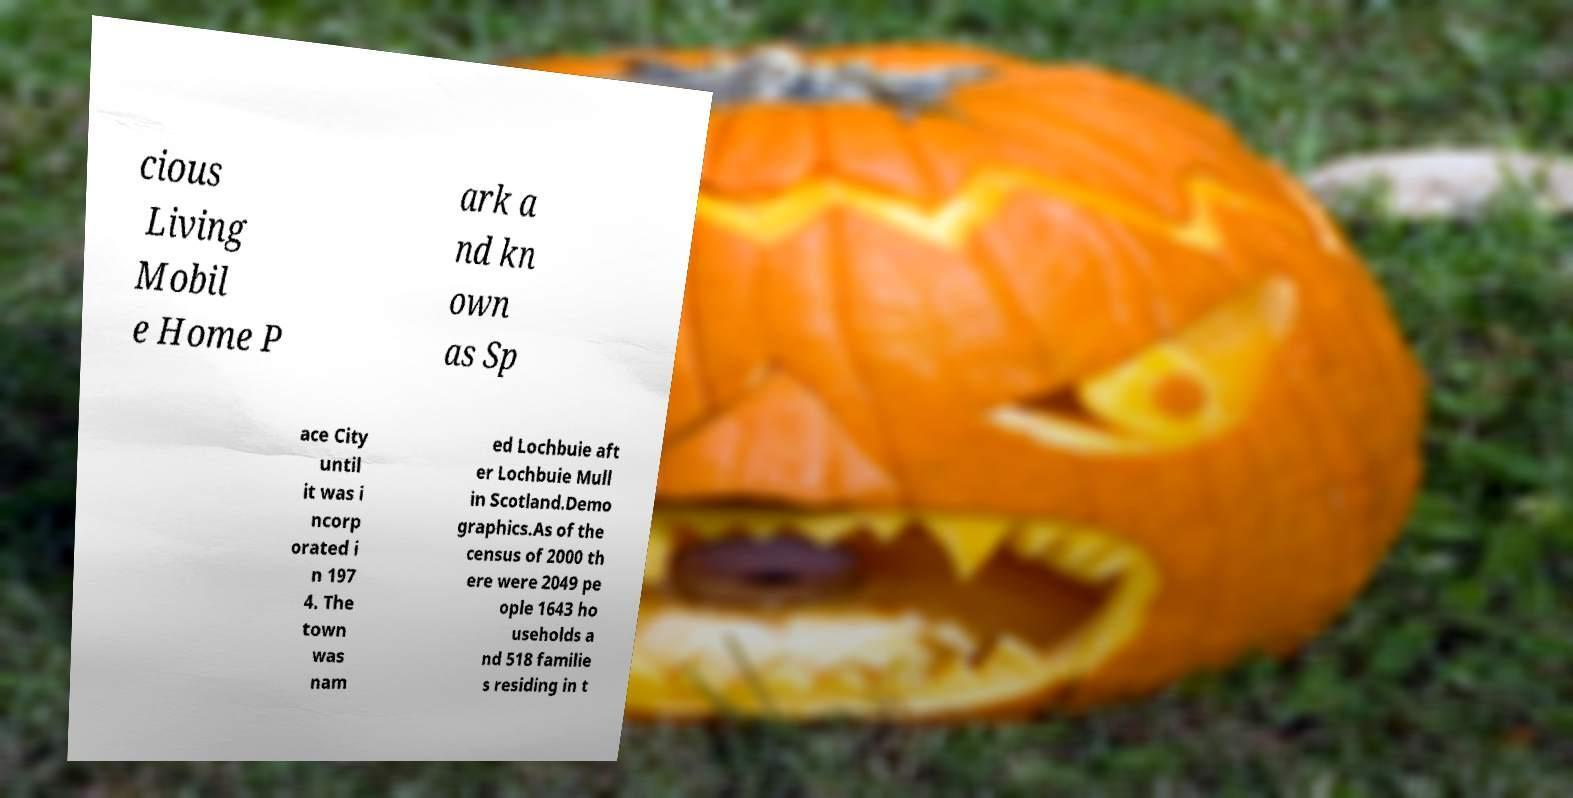Can you read and provide the text displayed in the image?This photo seems to have some interesting text. Can you extract and type it out for me? cious Living Mobil e Home P ark a nd kn own as Sp ace City until it was i ncorp orated i n 197 4. The town was nam ed Lochbuie aft er Lochbuie Mull in Scotland.Demo graphics.As of the census of 2000 th ere were 2049 pe ople 1643 ho useholds a nd 518 familie s residing in t 